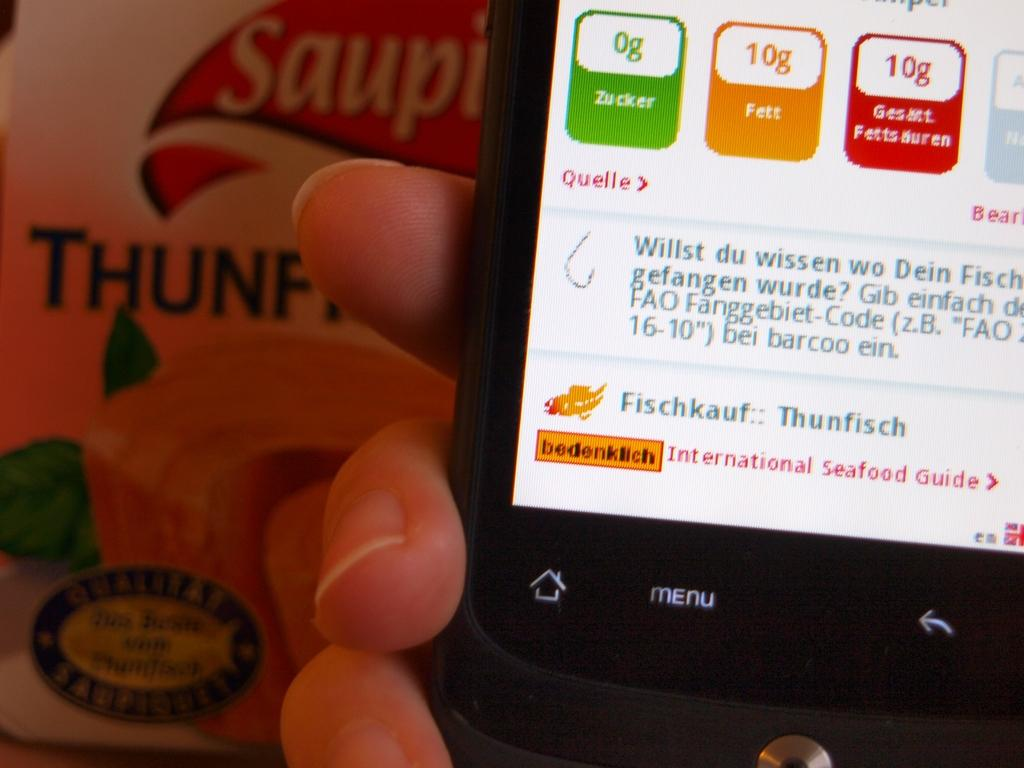Provide a one-sentence caption for the provided image. a phone with the name zucker on a green part. 